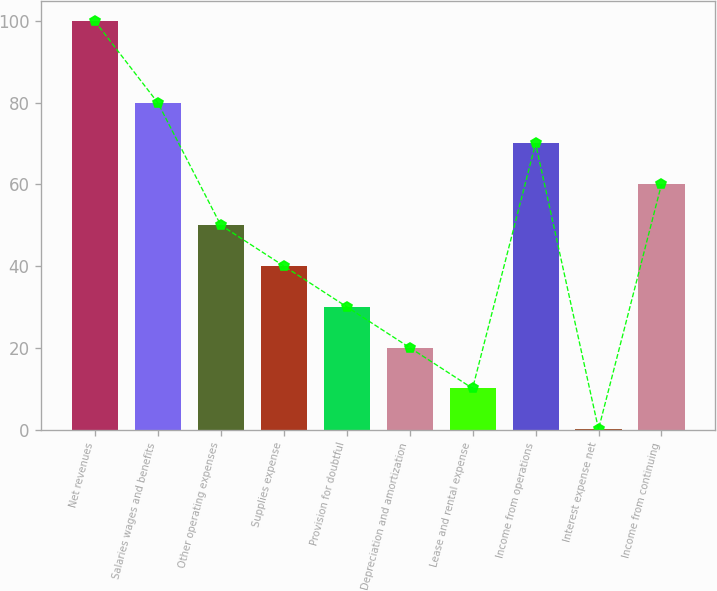<chart> <loc_0><loc_0><loc_500><loc_500><bar_chart><fcel>Net revenues<fcel>Salaries wages and benefits<fcel>Other operating expenses<fcel>Supplies expense<fcel>Provision for doubtful<fcel>Depreciation and amortization<fcel>Lease and rental expense<fcel>Income from operations<fcel>Interest expense net<fcel>Income from continuing<nl><fcel>100<fcel>80.02<fcel>50.05<fcel>40.06<fcel>30.07<fcel>20.08<fcel>10.09<fcel>70.03<fcel>0.1<fcel>60.04<nl></chart> 